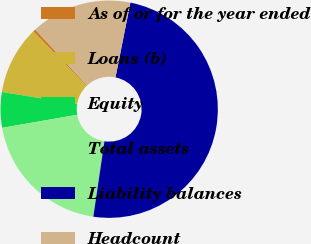Convert chart to OTSL. <chart><loc_0><loc_0><loc_500><loc_500><pie_chart><fcel>As of or for the year ended<fcel>Loans (b)<fcel>Equity<fcel>Total assets<fcel>Liability balances<fcel>Headcount<nl><fcel>0.4%<fcel>10.16%<fcel>5.28%<fcel>19.92%<fcel>49.2%<fcel>15.04%<nl></chart> 